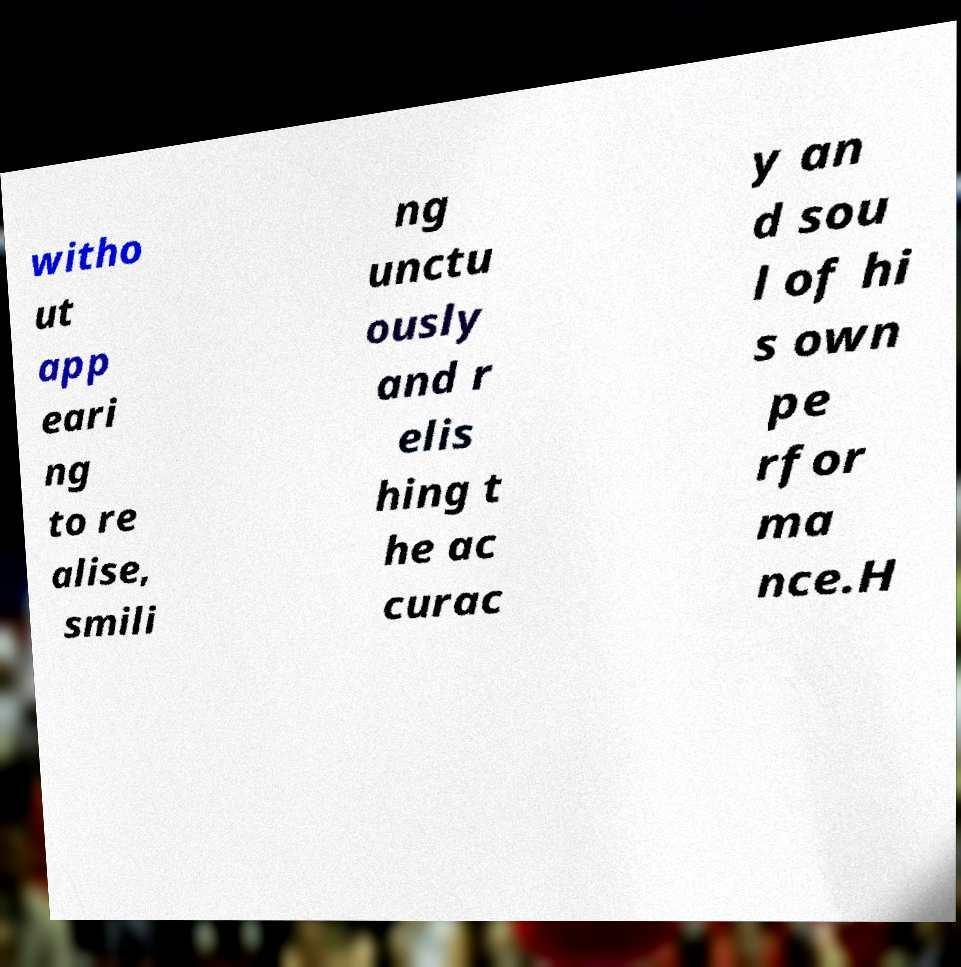Could you assist in decoding the text presented in this image and type it out clearly? witho ut app eari ng to re alise, smili ng unctu ously and r elis hing t he ac curac y an d sou l of hi s own pe rfor ma nce.H 